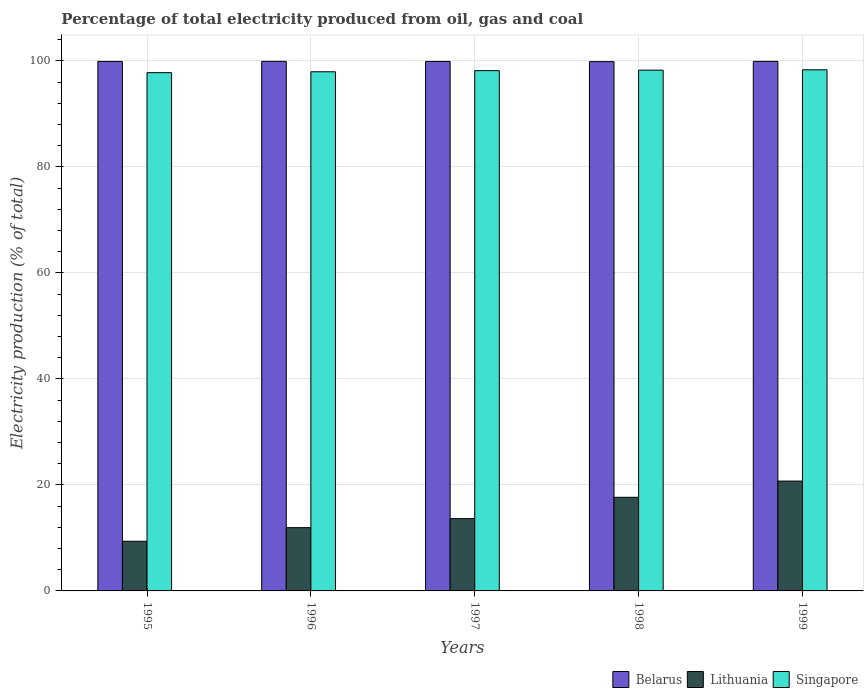How many groups of bars are there?
Offer a very short reply. 5. Are the number of bars on each tick of the X-axis equal?
Keep it short and to the point. Yes. In how many cases, is the number of bars for a given year not equal to the number of legend labels?
Your answer should be compact. 0. What is the electricity production in in Belarus in 1997?
Make the answer very short. 99.92. Across all years, what is the maximum electricity production in in Lithuania?
Your response must be concise. 20.73. Across all years, what is the minimum electricity production in in Singapore?
Make the answer very short. 97.8. In which year was the electricity production in in Singapore maximum?
Provide a succinct answer. 1999. In which year was the electricity production in in Singapore minimum?
Ensure brevity in your answer.  1995. What is the total electricity production in in Belarus in the graph?
Your answer should be compact. 499.58. What is the difference between the electricity production in in Belarus in 1996 and that in 1999?
Ensure brevity in your answer.  0. What is the difference between the electricity production in in Singapore in 1998 and the electricity production in in Lithuania in 1997?
Your answer should be very brief. 84.63. What is the average electricity production in in Singapore per year?
Offer a very short reply. 98.11. In the year 1999, what is the difference between the electricity production in in Belarus and electricity production in in Singapore?
Provide a succinct answer. 1.59. What is the ratio of the electricity production in in Belarus in 1995 to that in 1997?
Your answer should be compact. 1. What is the difference between the highest and the second highest electricity production in in Lithuania?
Offer a very short reply. 3.06. What is the difference between the highest and the lowest electricity production in in Singapore?
Provide a short and direct response. 0.54. In how many years, is the electricity production in in Lithuania greater than the average electricity production in in Lithuania taken over all years?
Your answer should be compact. 2. What does the 2nd bar from the left in 1999 represents?
Provide a short and direct response. Lithuania. What does the 2nd bar from the right in 1999 represents?
Your answer should be compact. Lithuania. Is it the case that in every year, the sum of the electricity production in in Singapore and electricity production in in Belarus is greater than the electricity production in in Lithuania?
Provide a short and direct response. Yes. Does the graph contain grids?
Provide a short and direct response. Yes. How are the legend labels stacked?
Ensure brevity in your answer.  Horizontal. What is the title of the graph?
Keep it short and to the point. Percentage of total electricity produced from oil, gas and coal. What is the label or title of the X-axis?
Your response must be concise. Years. What is the label or title of the Y-axis?
Your answer should be compact. Electricity production (% of total). What is the Electricity production (% of total) in Belarus in 1995?
Offer a terse response. 99.92. What is the Electricity production (% of total) in Lithuania in 1995?
Provide a short and direct response. 9.37. What is the Electricity production (% of total) of Singapore in 1995?
Ensure brevity in your answer.  97.8. What is the Electricity production (% of total) of Belarus in 1996?
Provide a succinct answer. 99.93. What is the Electricity production (% of total) of Lithuania in 1996?
Your answer should be very brief. 11.94. What is the Electricity production (% of total) of Singapore in 1996?
Ensure brevity in your answer.  97.97. What is the Electricity production (% of total) of Belarus in 1997?
Make the answer very short. 99.92. What is the Electricity production (% of total) of Lithuania in 1997?
Your response must be concise. 13.64. What is the Electricity production (% of total) of Singapore in 1997?
Give a very brief answer. 98.18. What is the Electricity production (% of total) in Belarus in 1998?
Keep it short and to the point. 99.88. What is the Electricity production (% of total) of Lithuania in 1998?
Ensure brevity in your answer.  17.66. What is the Electricity production (% of total) in Singapore in 1998?
Offer a very short reply. 98.27. What is the Electricity production (% of total) of Belarus in 1999?
Make the answer very short. 99.93. What is the Electricity production (% of total) in Lithuania in 1999?
Make the answer very short. 20.73. What is the Electricity production (% of total) in Singapore in 1999?
Provide a succinct answer. 98.34. Across all years, what is the maximum Electricity production (% of total) in Belarus?
Your response must be concise. 99.93. Across all years, what is the maximum Electricity production (% of total) of Lithuania?
Provide a succinct answer. 20.73. Across all years, what is the maximum Electricity production (% of total) of Singapore?
Provide a short and direct response. 98.34. Across all years, what is the minimum Electricity production (% of total) in Belarus?
Offer a very short reply. 99.88. Across all years, what is the minimum Electricity production (% of total) of Lithuania?
Provide a succinct answer. 9.37. Across all years, what is the minimum Electricity production (% of total) of Singapore?
Offer a terse response. 97.8. What is the total Electricity production (% of total) of Belarus in the graph?
Offer a terse response. 499.58. What is the total Electricity production (% of total) in Lithuania in the graph?
Your response must be concise. 73.35. What is the total Electricity production (% of total) in Singapore in the graph?
Your answer should be compact. 490.56. What is the difference between the Electricity production (% of total) of Belarus in 1995 and that in 1996?
Make the answer very short. -0.01. What is the difference between the Electricity production (% of total) of Lithuania in 1995 and that in 1996?
Make the answer very short. -2.57. What is the difference between the Electricity production (% of total) in Singapore in 1995 and that in 1996?
Your answer should be compact. -0.17. What is the difference between the Electricity production (% of total) of Lithuania in 1995 and that in 1997?
Your answer should be very brief. -4.27. What is the difference between the Electricity production (% of total) of Singapore in 1995 and that in 1997?
Give a very brief answer. -0.38. What is the difference between the Electricity production (% of total) in Belarus in 1995 and that in 1998?
Give a very brief answer. 0.04. What is the difference between the Electricity production (% of total) of Lithuania in 1995 and that in 1998?
Keep it short and to the point. -8.29. What is the difference between the Electricity production (% of total) in Singapore in 1995 and that in 1998?
Your answer should be compact. -0.48. What is the difference between the Electricity production (% of total) of Belarus in 1995 and that in 1999?
Keep it short and to the point. -0.01. What is the difference between the Electricity production (% of total) in Lithuania in 1995 and that in 1999?
Provide a short and direct response. -11.36. What is the difference between the Electricity production (% of total) in Singapore in 1995 and that in 1999?
Provide a short and direct response. -0.54. What is the difference between the Electricity production (% of total) of Belarus in 1996 and that in 1997?
Offer a terse response. 0.01. What is the difference between the Electricity production (% of total) in Lithuania in 1996 and that in 1997?
Keep it short and to the point. -1.7. What is the difference between the Electricity production (% of total) in Singapore in 1996 and that in 1997?
Offer a terse response. -0.21. What is the difference between the Electricity production (% of total) of Belarus in 1996 and that in 1998?
Your answer should be very brief. 0.05. What is the difference between the Electricity production (% of total) in Lithuania in 1996 and that in 1998?
Offer a terse response. -5.73. What is the difference between the Electricity production (% of total) of Singapore in 1996 and that in 1998?
Keep it short and to the point. -0.31. What is the difference between the Electricity production (% of total) of Belarus in 1996 and that in 1999?
Provide a short and direct response. 0. What is the difference between the Electricity production (% of total) of Lithuania in 1996 and that in 1999?
Offer a very short reply. -8.79. What is the difference between the Electricity production (% of total) of Singapore in 1996 and that in 1999?
Ensure brevity in your answer.  -0.37. What is the difference between the Electricity production (% of total) in Belarus in 1997 and that in 1998?
Keep it short and to the point. 0.04. What is the difference between the Electricity production (% of total) in Lithuania in 1997 and that in 1998?
Keep it short and to the point. -4.02. What is the difference between the Electricity production (% of total) of Singapore in 1997 and that in 1998?
Your response must be concise. -0.09. What is the difference between the Electricity production (% of total) of Belarus in 1997 and that in 1999?
Your response must be concise. -0.01. What is the difference between the Electricity production (% of total) of Lithuania in 1997 and that in 1999?
Your answer should be very brief. -7.08. What is the difference between the Electricity production (% of total) of Singapore in 1997 and that in 1999?
Provide a short and direct response. -0.16. What is the difference between the Electricity production (% of total) in Belarus in 1998 and that in 1999?
Provide a short and direct response. -0.05. What is the difference between the Electricity production (% of total) of Lithuania in 1998 and that in 1999?
Your response must be concise. -3.06. What is the difference between the Electricity production (% of total) of Singapore in 1998 and that in 1999?
Give a very brief answer. -0.07. What is the difference between the Electricity production (% of total) in Belarus in 1995 and the Electricity production (% of total) in Lithuania in 1996?
Provide a short and direct response. 87.98. What is the difference between the Electricity production (% of total) in Belarus in 1995 and the Electricity production (% of total) in Singapore in 1996?
Offer a terse response. 1.95. What is the difference between the Electricity production (% of total) in Lithuania in 1995 and the Electricity production (% of total) in Singapore in 1996?
Give a very brief answer. -88.6. What is the difference between the Electricity production (% of total) of Belarus in 1995 and the Electricity production (% of total) of Lithuania in 1997?
Ensure brevity in your answer.  86.28. What is the difference between the Electricity production (% of total) in Belarus in 1995 and the Electricity production (% of total) in Singapore in 1997?
Your response must be concise. 1.74. What is the difference between the Electricity production (% of total) of Lithuania in 1995 and the Electricity production (% of total) of Singapore in 1997?
Provide a short and direct response. -88.81. What is the difference between the Electricity production (% of total) in Belarus in 1995 and the Electricity production (% of total) in Lithuania in 1998?
Your answer should be compact. 82.26. What is the difference between the Electricity production (% of total) in Belarus in 1995 and the Electricity production (% of total) in Singapore in 1998?
Give a very brief answer. 1.65. What is the difference between the Electricity production (% of total) of Lithuania in 1995 and the Electricity production (% of total) of Singapore in 1998?
Provide a succinct answer. -88.9. What is the difference between the Electricity production (% of total) of Belarus in 1995 and the Electricity production (% of total) of Lithuania in 1999?
Your answer should be very brief. 79.19. What is the difference between the Electricity production (% of total) in Belarus in 1995 and the Electricity production (% of total) in Singapore in 1999?
Your answer should be very brief. 1.58. What is the difference between the Electricity production (% of total) of Lithuania in 1995 and the Electricity production (% of total) of Singapore in 1999?
Offer a terse response. -88.97. What is the difference between the Electricity production (% of total) of Belarus in 1996 and the Electricity production (% of total) of Lithuania in 1997?
Offer a terse response. 86.29. What is the difference between the Electricity production (% of total) of Belarus in 1996 and the Electricity production (% of total) of Singapore in 1997?
Give a very brief answer. 1.75. What is the difference between the Electricity production (% of total) of Lithuania in 1996 and the Electricity production (% of total) of Singapore in 1997?
Your answer should be compact. -86.24. What is the difference between the Electricity production (% of total) in Belarus in 1996 and the Electricity production (% of total) in Lithuania in 1998?
Offer a very short reply. 82.27. What is the difference between the Electricity production (% of total) of Belarus in 1996 and the Electricity production (% of total) of Singapore in 1998?
Provide a short and direct response. 1.66. What is the difference between the Electricity production (% of total) in Lithuania in 1996 and the Electricity production (% of total) in Singapore in 1998?
Your answer should be very brief. -86.33. What is the difference between the Electricity production (% of total) in Belarus in 1996 and the Electricity production (% of total) in Lithuania in 1999?
Offer a very short reply. 79.21. What is the difference between the Electricity production (% of total) in Belarus in 1996 and the Electricity production (% of total) in Singapore in 1999?
Offer a very short reply. 1.59. What is the difference between the Electricity production (% of total) of Lithuania in 1996 and the Electricity production (% of total) of Singapore in 1999?
Keep it short and to the point. -86.4. What is the difference between the Electricity production (% of total) in Belarus in 1997 and the Electricity production (% of total) in Lithuania in 1998?
Give a very brief answer. 82.25. What is the difference between the Electricity production (% of total) in Belarus in 1997 and the Electricity production (% of total) in Singapore in 1998?
Offer a terse response. 1.65. What is the difference between the Electricity production (% of total) of Lithuania in 1997 and the Electricity production (% of total) of Singapore in 1998?
Your answer should be compact. -84.63. What is the difference between the Electricity production (% of total) in Belarus in 1997 and the Electricity production (% of total) in Lithuania in 1999?
Your response must be concise. 79.19. What is the difference between the Electricity production (% of total) of Belarus in 1997 and the Electricity production (% of total) of Singapore in 1999?
Provide a short and direct response. 1.58. What is the difference between the Electricity production (% of total) in Lithuania in 1997 and the Electricity production (% of total) in Singapore in 1999?
Your answer should be very brief. -84.7. What is the difference between the Electricity production (% of total) in Belarus in 1998 and the Electricity production (% of total) in Lithuania in 1999?
Offer a very short reply. 79.15. What is the difference between the Electricity production (% of total) of Belarus in 1998 and the Electricity production (% of total) of Singapore in 1999?
Make the answer very short. 1.54. What is the difference between the Electricity production (% of total) of Lithuania in 1998 and the Electricity production (% of total) of Singapore in 1999?
Your answer should be very brief. -80.68. What is the average Electricity production (% of total) in Belarus per year?
Your response must be concise. 99.92. What is the average Electricity production (% of total) of Lithuania per year?
Your answer should be compact. 14.67. What is the average Electricity production (% of total) of Singapore per year?
Ensure brevity in your answer.  98.11. In the year 1995, what is the difference between the Electricity production (% of total) of Belarus and Electricity production (% of total) of Lithuania?
Offer a terse response. 90.55. In the year 1995, what is the difference between the Electricity production (% of total) in Belarus and Electricity production (% of total) in Singapore?
Offer a very short reply. 2.12. In the year 1995, what is the difference between the Electricity production (% of total) of Lithuania and Electricity production (% of total) of Singapore?
Keep it short and to the point. -88.43. In the year 1996, what is the difference between the Electricity production (% of total) in Belarus and Electricity production (% of total) in Lithuania?
Keep it short and to the point. 87.99. In the year 1996, what is the difference between the Electricity production (% of total) of Belarus and Electricity production (% of total) of Singapore?
Provide a short and direct response. 1.97. In the year 1996, what is the difference between the Electricity production (% of total) in Lithuania and Electricity production (% of total) in Singapore?
Your response must be concise. -86.03. In the year 1997, what is the difference between the Electricity production (% of total) in Belarus and Electricity production (% of total) in Lithuania?
Offer a very short reply. 86.28. In the year 1997, what is the difference between the Electricity production (% of total) of Belarus and Electricity production (% of total) of Singapore?
Provide a short and direct response. 1.74. In the year 1997, what is the difference between the Electricity production (% of total) in Lithuania and Electricity production (% of total) in Singapore?
Make the answer very short. -84.53. In the year 1998, what is the difference between the Electricity production (% of total) in Belarus and Electricity production (% of total) in Lithuania?
Your response must be concise. 82.22. In the year 1998, what is the difference between the Electricity production (% of total) of Belarus and Electricity production (% of total) of Singapore?
Provide a succinct answer. 1.61. In the year 1998, what is the difference between the Electricity production (% of total) of Lithuania and Electricity production (% of total) of Singapore?
Offer a very short reply. -80.61. In the year 1999, what is the difference between the Electricity production (% of total) in Belarus and Electricity production (% of total) in Lithuania?
Your response must be concise. 79.2. In the year 1999, what is the difference between the Electricity production (% of total) in Belarus and Electricity production (% of total) in Singapore?
Provide a short and direct response. 1.59. In the year 1999, what is the difference between the Electricity production (% of total) of Lithuania and Electricity production (% of total) of Singapore?
Your response must be concise. -77.61. What is the ratio of the Electricity production (% of total) in Belarus in 1995 to that in 1996?
Make the answer very short. 1. What is the ratio of the Electricity production (% of total) in Lithuania in 1995 to that in 1996?
Provide a succinct answer. 0.78. What is the ratio of the Electricity production (% of total) of Singapore in 1995 to that in 1996?
Provide a succinct answer. 1. What is the ratio of the Electricity production (% of total) in Lithuania in 1995 to that in 1997?
Offer a very short reply. 0.69. What is the ratio of the Electricity production (% of total) of Belarus in 1995 to that in 1998?
Your answer should be very brief. 1. What is the ratio of the Electricity production (% of total) of Lithuania in 1995 to that in 1998?
Make the answer very short. 0.53. What is the ratio of the Electricity production (% of total) in Singapore in 1995 to that in 1998?
Offer a terse response. 1. What is the ratio of the Electricity production (% of total) of Lithuania in 1995 to that in 1999?
Your answer should be very brief. 0.45. What is the ratio of the Electricity production (% of total) of Lithuania in 1996 to that in 1997?
Make the answer very short. 0.88. What is the ratio of the Electricity production (% of total) of Singapore in 1996 to that in 1997?
Provide a short and direct response. 1. What is the ratio of the Electricity production (% of total) of Belarus in 1996 to that in 1998?
Make the answer very short. 1. What is the ratio of the Electricity production (% of total) of Lithuania in 1996 to that in 1998?
Provide a short and direct response. 0.68. What is the ratio of the Electricity production (% of total) of Singapore in 1996 to that in 1998?
Offer a terse response. 1. What is the ratio of the Electricity production (% of total) of Lithuania in 1996 to that in 1999?
Keep it short and to the point. 0.58. What is the ratio of the Electricity production (% of total) of Lithuania in 1997 to that in 1998?
Keep it short and to the point. 0.77. What is the ratio of the Electricity production (% of total) in Belarus in 1997 to that in 1999?
Keep it short and to the point. 1. What is the ratio of the Electricity production (% of total) in Lithuania in 1997 to that in 1999?
Offer a terse response. 0.66. What is the ratio of the Electricity production (% of total) of Lithuania in 1998 to that in 1999?
Offer a terse response. 0.85. What is the difference between the highest and the second highest Electricity production (% of total) of Belarus?
Keep it short and to the point. 0. What is the difference between the highest and the second highest Electricity production (% of total) in Lithuania?
Offer a very short reply. 3.06. What is the difference between the highest and the second highest Electricity production (% of total) in Singapore?
Make the answer very short. 0.07. What is the difference between the highest and the lowest Electricity production (% of total) of Belarus?
Offer a terse response. 0.05. What is the difference between the highest and the lowest Electricity production (% of total) in Lithuania?
Offer a very short reply. 11.36. What is the difference between the highest and the lowest Electricity production (% of total) of Singapore?
Give a very brief answer. 0.54. 